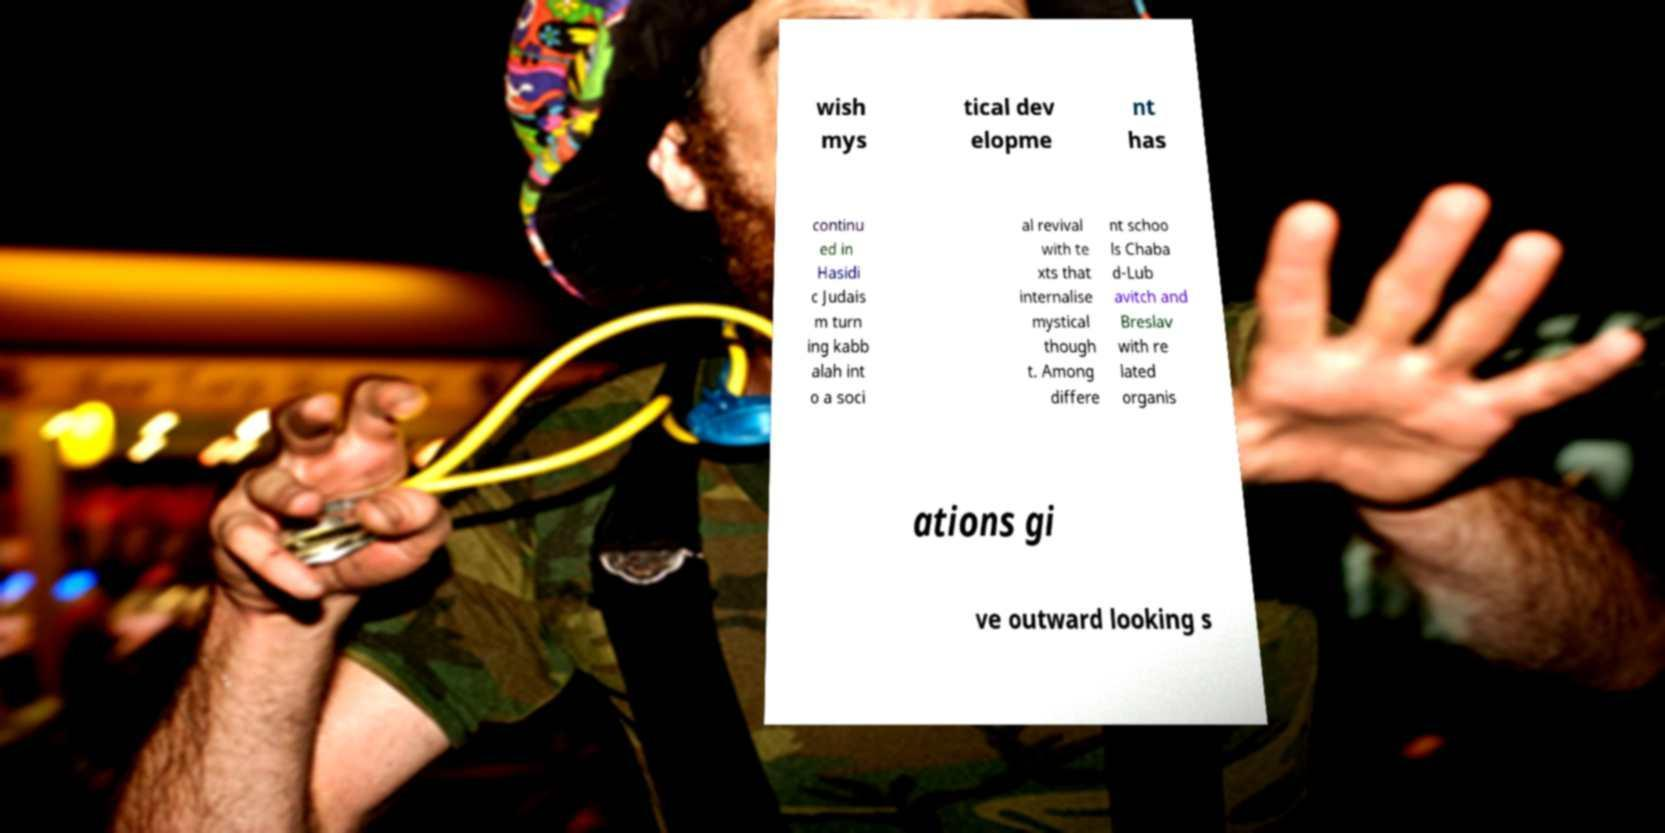For documentation purposes, I need the text within this image transcribed. Could you provide that? wish mys tical dev elopme nt has continu ed in Hasidi c Judais m turn ing kabb alah int o a soci al revival with te xts that internalise mystical though t. Among differe nt schoo ls Chaba d-Lub avitch and Breslav with re lated organis ations gi ve outward looking s 